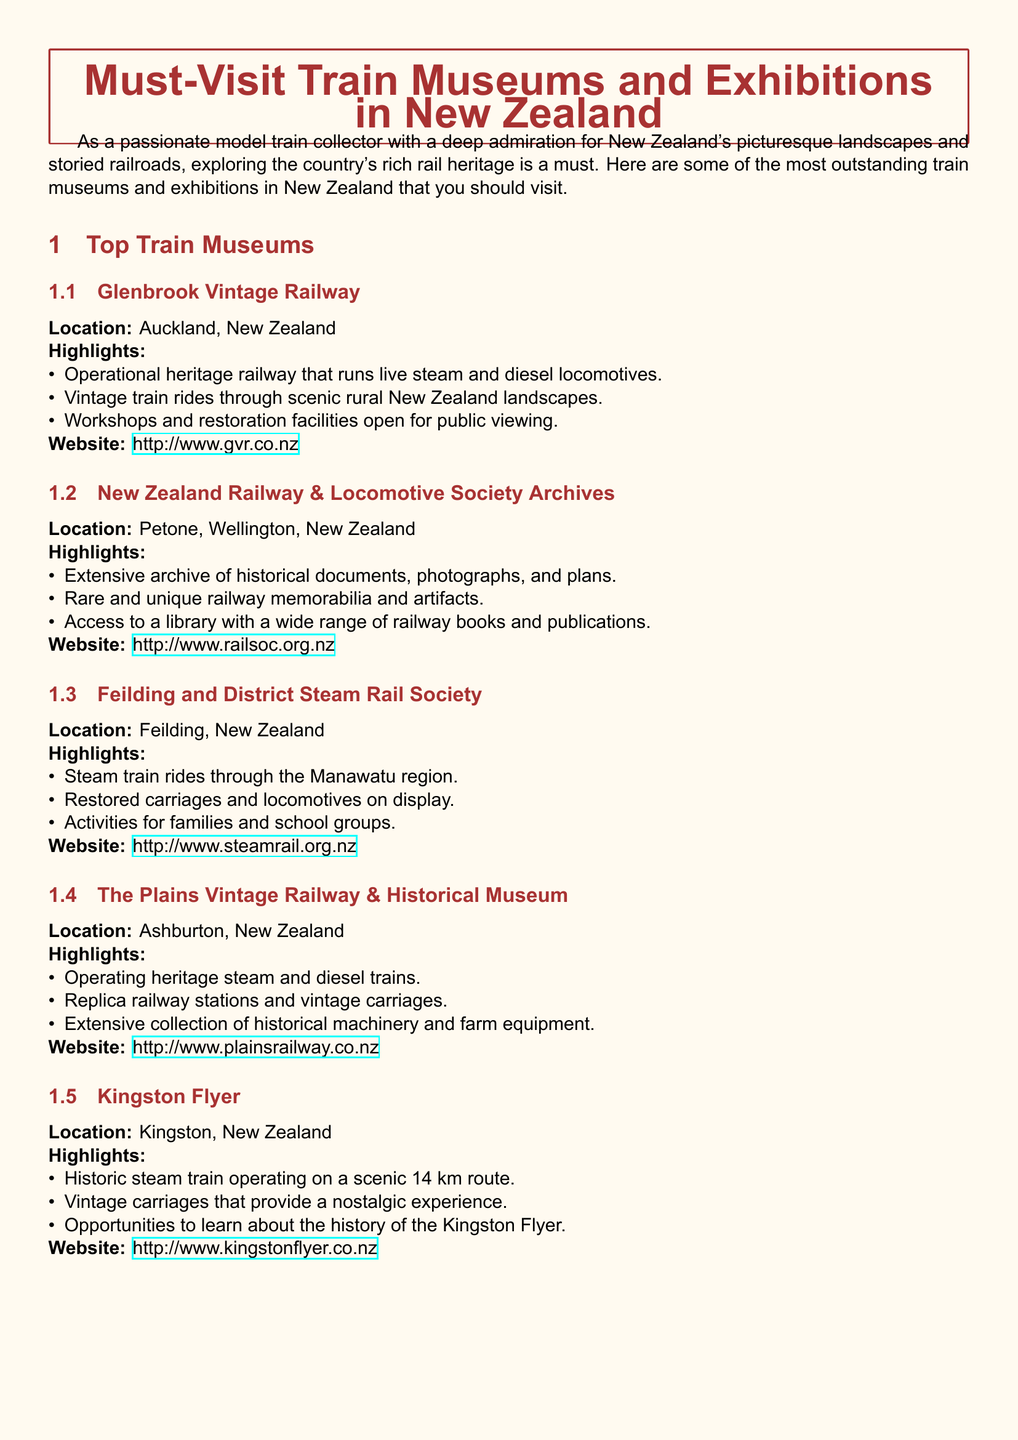What is the location of the Glenbrook Vintage Railway? The location is listed as Auckland, New Zealand.
Answer: Auckland, New Zealand How many highlights does the Feilding and District Steam Rail Society have? The document lists three main highlights for this museum.
Answer: Three What type of train rides are offered at The Plains Vintage Railway & Historical Museum? The document states that this museum offers operational heritage steam and diesel trains.
Answer: Steam and diesel trains Which museum has a library with a wide range of railway books? The New Zealand Railway & Locomotive Society Archives is mentioned to have access to a library.
Answer: New Zealand Railway & Locomotive Society Archives What is the website for the Kingston Flyer? The document provides the specific website link for the Kingston Flyer.
Answer: www.kingstonflyer.co.nz What kind of exhibits does the Feilding and District Steam Rail Society feature? The highlights mention restored carriages and locomotives on display.
Answer: Restored carriages and locomotives Which museum is located in Ashburton, New Zealand? The Plains Vintage Railway & Historical Museum is identified as being in Ashburton.
Answer: The Plains Vintage Railway & Historical Museum What kind of railway does the Glenbrook Vintage Railway operate? It operates a heritage railway that runs live steam and diesel locomotives.
Answer: Heritage railway How far is the scenic route of the Kingston Flyer? The document states the route is 14 km long.
Answer: 14 km 